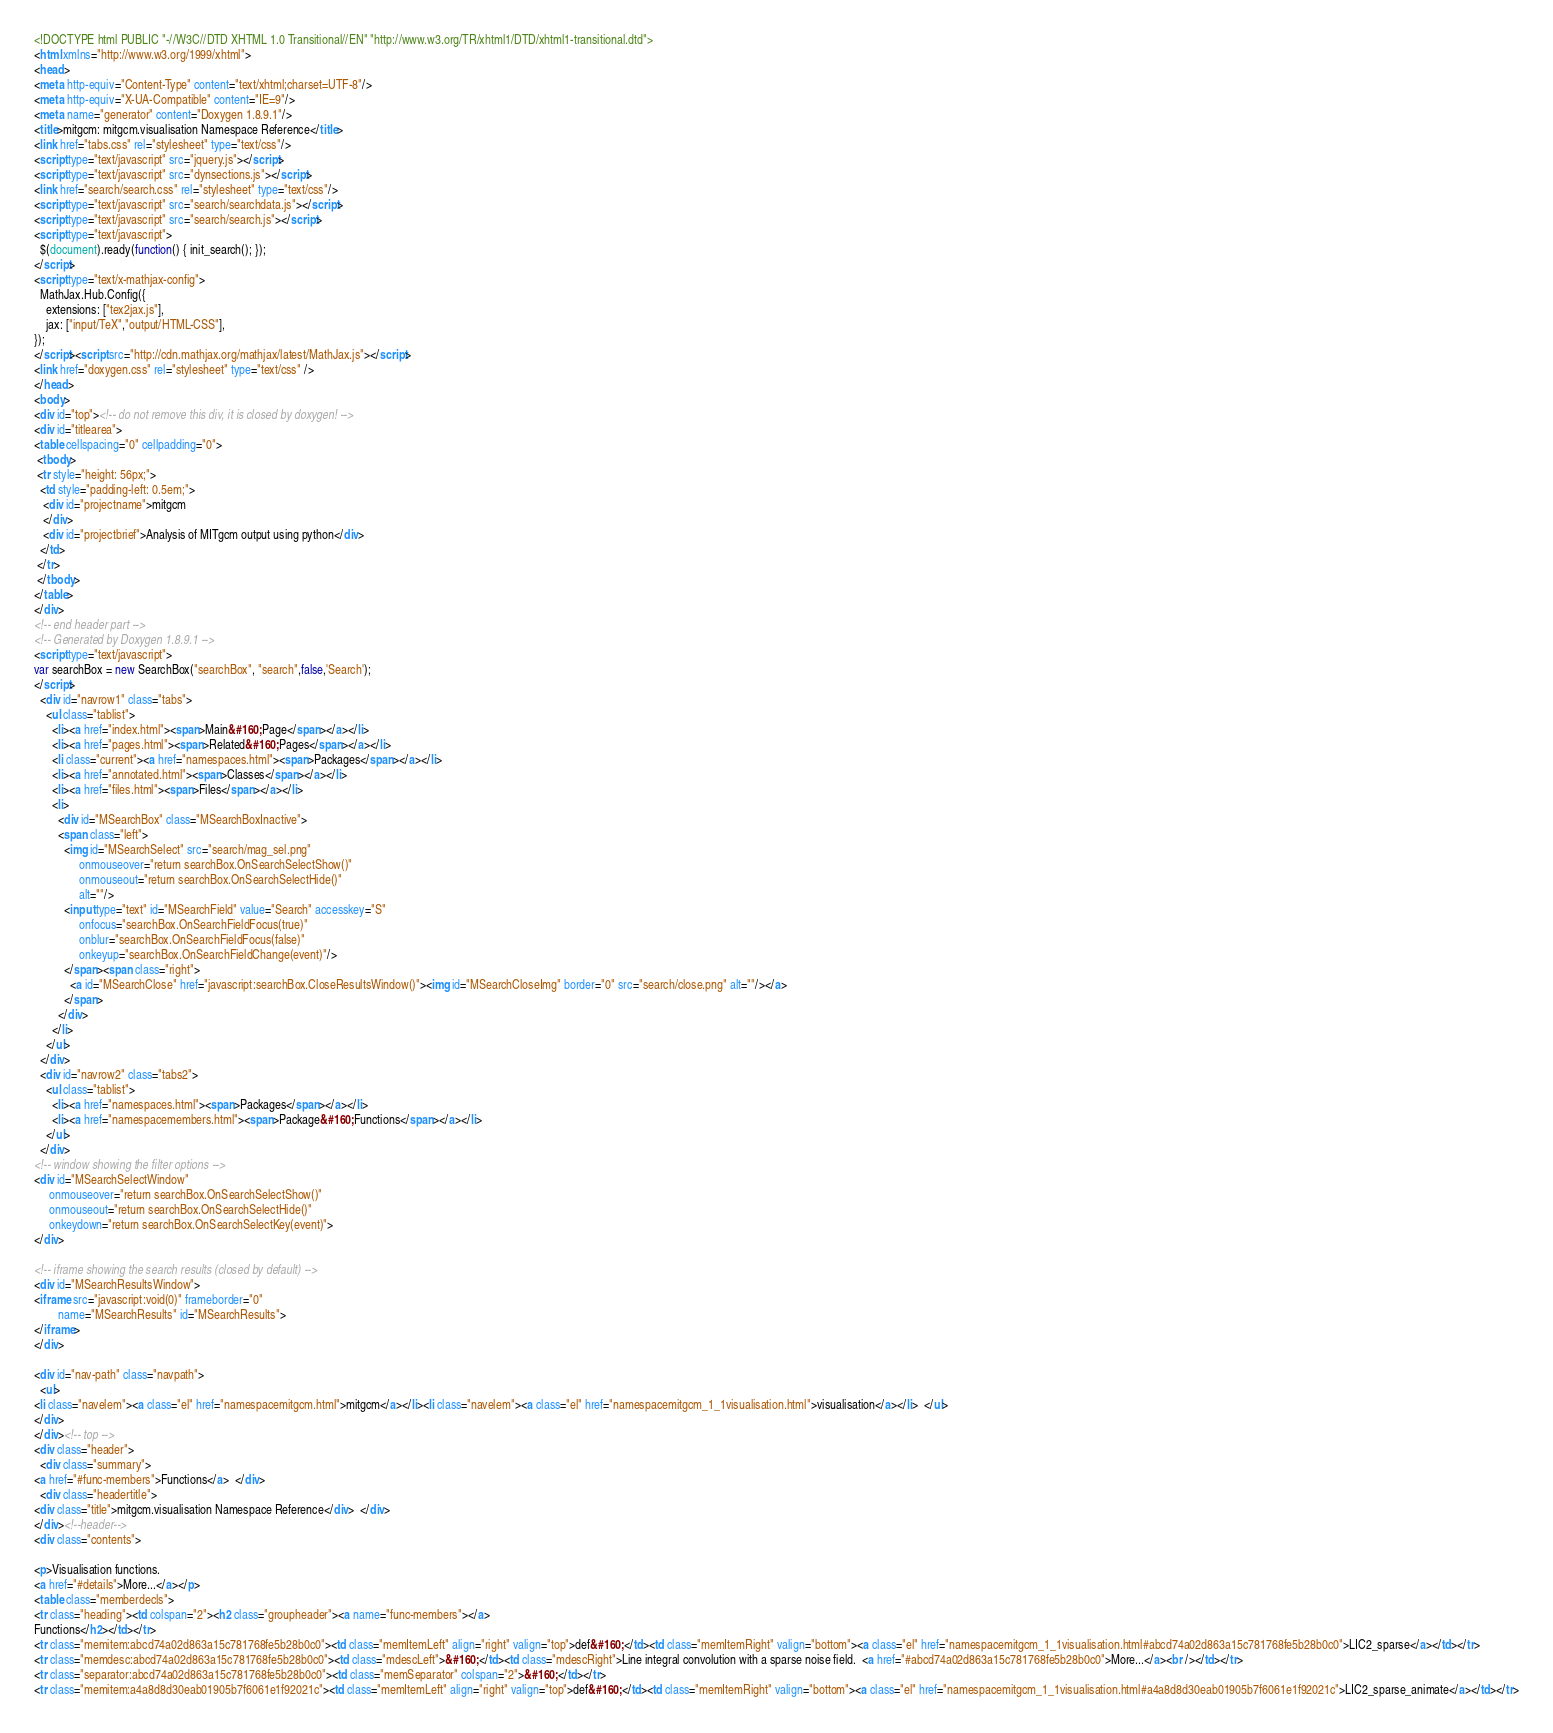<code> <loc_0><loc_0><loc_500><loc_500><_HTML_><!DOCTYPE html PUBLIC "-//W3C//DTD XHTML 1.0 Transitional//EN" "http://www.w3.org/TR/xhtml1/DTD/xhtml1-transitional.dtd">
<html xmlns="http://www.w3.org/1999/xhtml">
<head>
<meta http-equiv="Content-Type" content="text/xhtml;charset=UTF-8"/>
<meta http-equiv="X-UA-Compatible" content="IE=9"/>
<meta name="generator" content="Doxygen 1.8.9.1"/>
<title>mitgcm: mitgcm.visualisation Namespace Reference</title>
<link href="tabs.css" rel="stylesheet" type="text/css"/>
<script type="text/javascript" src="jquery.js"></script>
<script type="text/javascript" src="dynsections.js"></script>
<link href="search/search.css" rel="stylesheet" type="text/css"/>
<script type="text/javascript" src="search/searchdata.js"></script>
<script type="text/javascript" src="search/search.js"></script>
<script type="text/javascript">
  $(document).ready(function() { init_search(); });
</script>
<script type="text/x-mathjax-config">
  MathJax.Hub.Config({
    extensions: ["tex2jax.js"],
    jax: ["input/TeX","output/HTML-CSS"],
});
</script><script src="http://cdn.mathjax.org/mathjax/latest/MathJax.js"></script>
<link href="doxygen.css" rel="stylesheet" type="text/css" />
</head>
<body>
<div id="top"><!-- do not remove this div, it is closed by doxygen! -->
<div id="titlearea">
<table cellspacing="0" cellpadding="0">
 <tbody>
 <tr style="height: 56px;">
  <td style="padding-left: 0.5em;">
   <div id="projectname">mitgcm
   </div>
   <div id="projectbrief">Analysis of MITgcm output using python</div>
  </td>
 </tr>
 </tbody>
</table>
</div>
<!-- end header part -->
<!-- Generated by Doxygen 1.8.9.1 -->
<script type="text/javascript">
var searchBox = new SearchBox("searchBox", "search",false,'Search');
</script>
  <div id="navrow1" class="tabs">
    <ul class="tablist">
      <li><a href="index.html"><span>Main&#160;Page</span></a></li>
      <li><a href="pages.html"><span>Related&#160;Pages</span></a></li>
      <li class="current"><a href="namespaces.html"><span>Packages</span></a></li>
      <li><a href="annotated.html"><span>Classes</span></a></li>
      <li><a href="files.html"><span>Files</span></a></li>
      <li>
        <div id="MSearchBox" class="MSearchBoxInactive">
        <span class="left">
          <img id="MSearchSelect" src="search/mag_sel.png"
               onmouseover="return searchBox.OnSearchSelectShow()"
               onmouseout="return searchBox.OnSearchSelectHide()"
               alt=""/>
          <input type="text" id="MSearchField" value="Search" accesskey="S"
               onfocus="searchBox.OnSearchFieldFocus(true)" 
               onblur="searchBox.OnSearchFieldFocus(false)" 
               onkeyup="searchBox.OnSearchFieldChange(event)"/>
          </span><span class="right">
            <a id="MSearchClose" href="javascript:searchBox.CloseResultsWindow()"><img id="MSearchCloseImg" border="0" src="search/close.png" alt=""/></a>
          </span>
        </div>
      </li>
    </ul>
  </div>
  <div id="navrow2" class="tabs2">
    <ul class="tablist">
      <li><a href="namespaces.html"><span>Packages</span></a></li>
      <li><a href="namespacemembers.html"><span>Package&#160;Functions</span></a></li>
    </ul>
  </div>
<!-- window showing the filter options -->
<div id="MSearchSelectWindow"
     onmouseover="return searchBox.OnSearchSelectShow()"
     onmouseout="return searchBox.OnSearchSelectHide()"
     onkeydown="return searchBox.OnSearchSelectKey(event)">
</div>

<!-- iframe showing the search results (closed by default) -->
<div id="MSearchResultsWindow">
<iframe src="javascript:void(0)" frameborder="0" 
        name="MSearchResults" id="MSearchResults">
</iframe>
</div>

<div id="nav-path" class="navpath">
  <ul>
<li class="navelem"><a class="el" href="namespacemitgcm.html">mitgcm</a></li><li class="navelem"><a class="el" href="namespacemitgcm_1_1visualisation.html">visualisation</a></li>  </ul>
</div>
</div><!-- top -->
<div class="header">
  <div class="summary">
<a href="#func-members">Functions</a>  </div>
  <div class="headertitle">
<div class="title">mitgcm.visualisation Namespace Reference</div>  </div>
</div><!--header-->
<div class="contents">

<p>Visualisation functions.  
<a href="#details">More...</a></p>
<table class="memberdecls">
<tr class="heading"><td colspan="2"><h2 class="groupheader"><a name="func-members"></a>
Functions</h2></td></tr>
<tr class="memitem:abcd74a02d863a15c781768fe5b28b0c0"><td class="memItemLeft" align="right" valign="top">def&#160;</td><td class="memItemRight" valign="bottom"><a class="el" href="namespacemitgcm_1_1visualisation.html#abcd74a02d863a15c781768fe5b28b0c0">LIC2_sparse</a></td></tr>
<tr class="memdesc:abcd74a02d863a15c781768fe5b28b0c0"><td class="mdescLeft">&#160;</td><td class="mdescRight">Line integral convolution with a sparse noise field.  <a href="#abcd74a02d863a15c781768fe5b28b0c0">More...</a><br /></td></tr>
<tr class="separator:abcd74a02d863a15c781768fe5b28b0c0"><td class="memSeparator" colspan="2">&#160;</td></tr>
<tr class="memitem:a4a8d8d30eab01905b7f6061e1f92021c"><td class="memItemLeft" align="right" valign="top">def&#160;</td><td class="memItemRight" valign="bottom"><a class="el" href="namespacemitgcm_1_1visualisation.html#a4a8d8d30eab01905b7f6061e1f92021c">LIC2_sparse_animate</a></td></tr></code> 